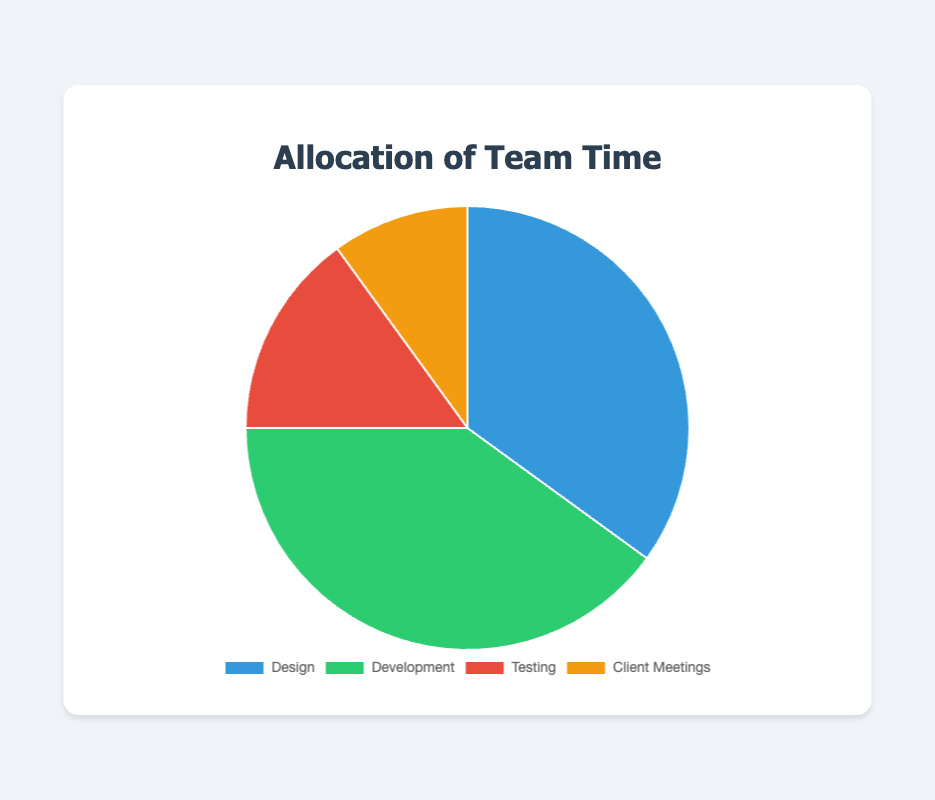What percentage of the team's time is allocated to development? The chart shows the percentage labeled as 'Development', which is 40%.
Answer: 40% Which category has the smallest allocation of team time? By examining the pie chart, the smallest slice corresponds to 'Client Meetings', labeled as 10%.
Answer: Client Meetings What is the combined percentage of time allocated to Design and Testing? The 'Design' slice is 35% and the 'Testing' slice is 15%. Summing these gives 35% + 15% = 50%.
Answer: 50% How does the time spent on Client Meetings compare to Testing? 'Client Meetings' is 10% and 'Testing' is 15%. Since 10% < 15%, the time spent on Client Meetings is less than Testing.
Answer: Less What’s the difference in time allocation between Development and Design? 'Development' is 40% and 'Design' is 35%. The difference is 40% - 35% = 5%.
Answer: 5% If the total team time were divided equally among the four categories, what would be the percentage for each? Dividing 100% by 4 categories gives 100% / 4 = 25% for each category.
Answer: 25% What fraction of the total team time is spent on activities other than Development? Development is 40%, so the remaining time is 100% - 40% = 60%.
Answer: 60% Which category's allocation is closest to the average percentage of all categories? The average is (35% + 40% + 15% + 10%) / 4 = 25%. The category closest to 25% is 'Testing' at 15% (15% is closer to 25% than 10%).
Answer: Testing What percentage of the team's time is allocated to non-design activities? Design is 35%, so non-design allocation is 100% - 35% = 65%.
Answer: 65% How does the time allocated to Development compare in visual size to the time allocated to Client Meetings in the pie chart? 'Development' appears larger than 'Client Meetings' since 40% > 10%. Thus, the slice for 'Development' takes up more space in the pie chart than the slice for 'Client Meetings'.
Answer: Larger 